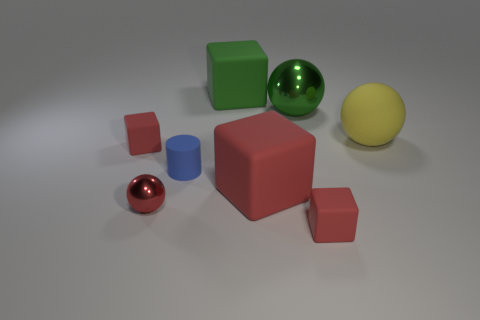There is a thing that is in front of the large yellow object and to the right of the big red cube; what color is it?
Provide a short and direct response. Red. Is the tiny red block behind the tiny ball made of the same material as the tiny block that is in front of the blue rubber thing?
Offer a very short reply. Yes. Does the matte cube left of the red metal ball have the same size as the red sphere?
Ensure brevity in your answer.  Yes. Is the color of the large metallic object the same as the large cube behind the blue cylinder?
Provide a short and direct response. Yes. There is a large object that is the same color as the tiny shiny object; what shape is it?
Provide a succinct answer. Cube. What shape is the red metallic thing?
Give a very brief answer. Sphere. What number of things are either small cubes on the left side of the tiny red ball or large red matte cylinders?
Give a very brief answer. 1. What is the size of the green thing that is made of the same material as the red sphere?
Make the answer very short. Large. Are there more yellow matte spheres to the right of the large green rubber block than gray rubber things?
Offer a terse response. Yes. Do the big green metal thing and the yellow thing behind the large red rubber cube have the same shape?
Provide a short and direct response. Yes. 